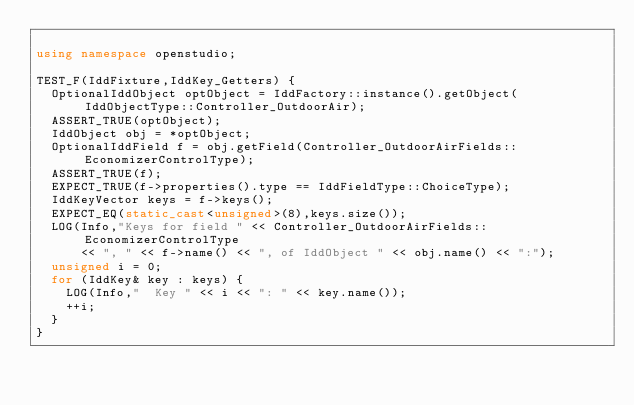Convert code to text. <code><loc_0><loc_0><loc_500><loc_500><_C++_>
using namespace openstudio;

TEST_F(IddFixture,IddKey_Getters) {
  OptionalIddObject optObject = IddFactory::instance().getObject(IddObjectType::Controller_OutdoorAir);
  ASSERT_TRUE(optObject);
  IddObject obj = *optObject;
  OptionalIddField f = obj.getField(Controller_OutdoorAirFields::EconomizerControlType);
  ASSERT_TRUE(f);
  EXPECT_TRUE(f->properties().type == IddFieldType::ChoiceType);
  IddKeyVector keys = f->keys();
  EXPECT_EQ(static_cast<unsigned>(8),keys.size());
  LOG(Info,"Keys for field " << Controller_OutdoorAirFields::EconomizerControlType
      << ", " << f->name() << ", of IddObject " << obj.name() << ":");
  unsigned i = 0;
  for (IddKey& key : keys) {
    LOG(Info,"  Key " << i << ": " << key.name());
    ++i;
  }
}
</code> 